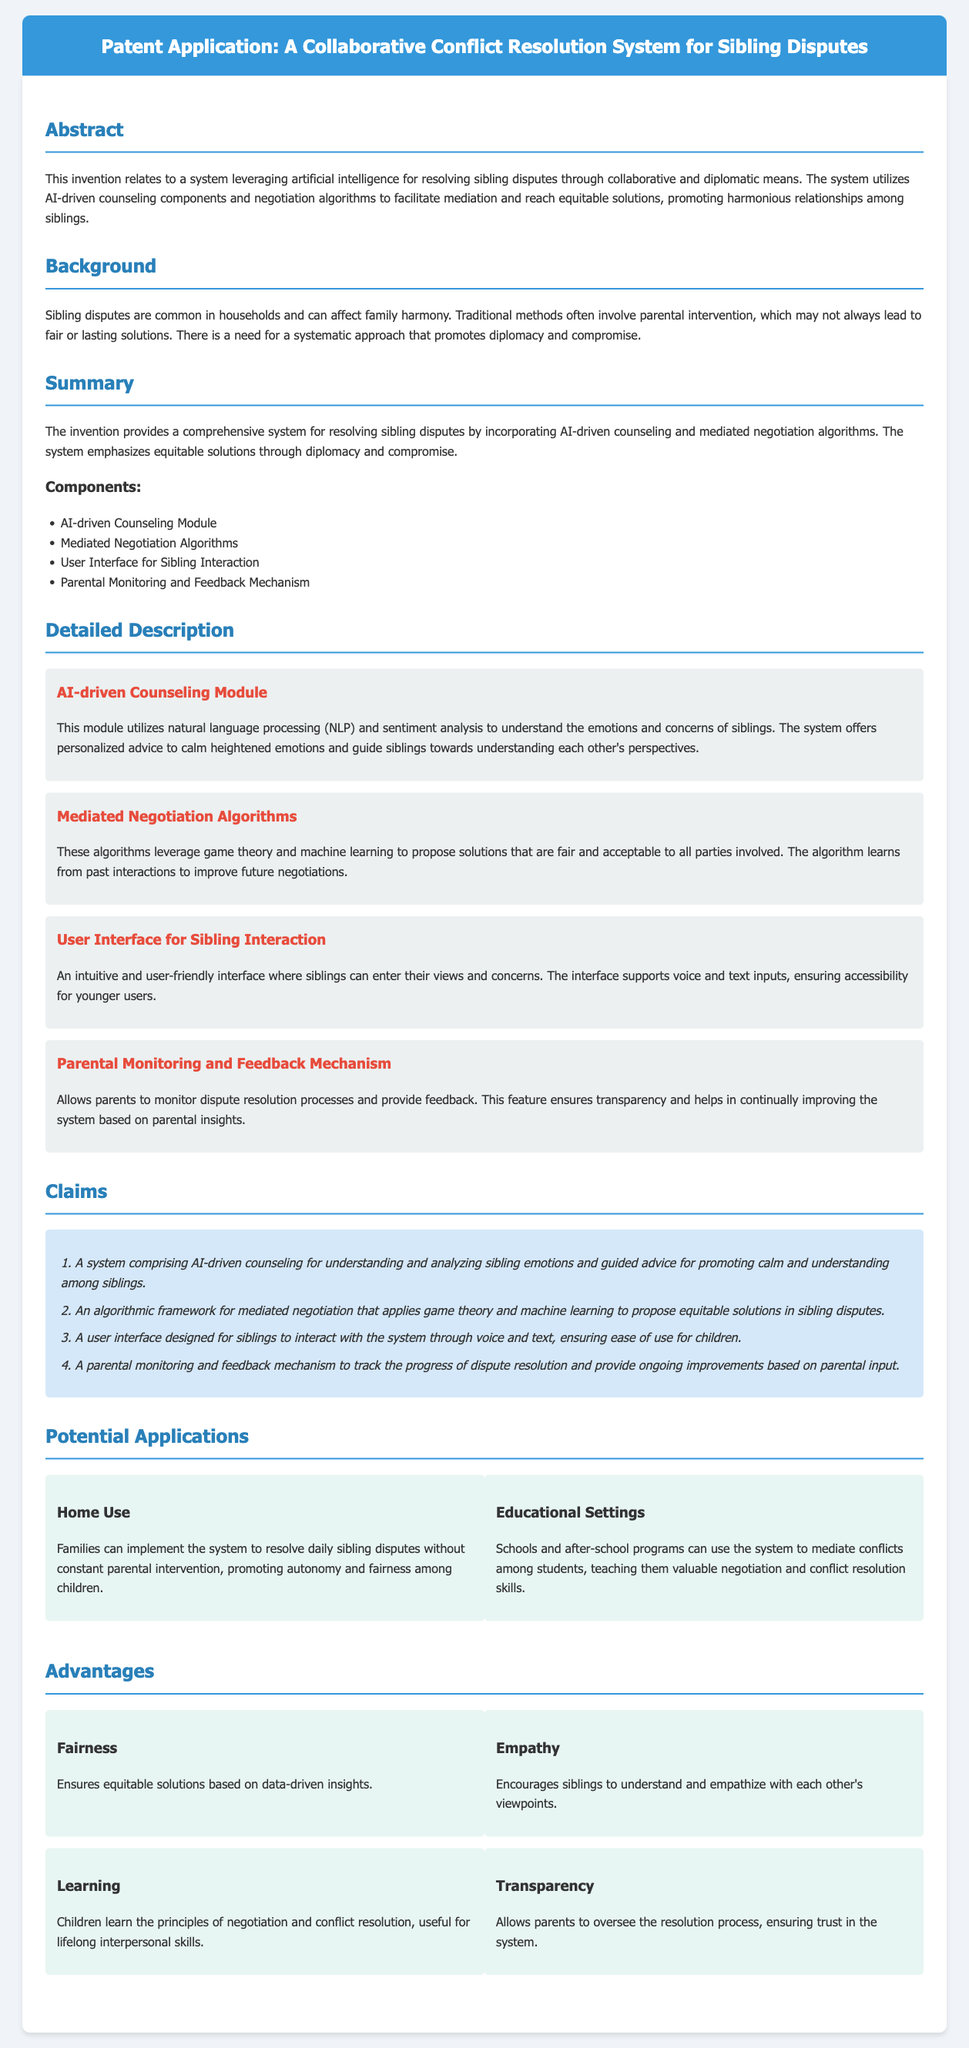What is the main purpose of the invention? The invention aims to resolve sibling disputes through collaborative and diplomatic means.
Answer: resolving sibling disputes What module uses natural language processing? The module that uses natural language processing is designed to understand emotions and concerns of siblings.
Answer: AI-driven Counseling Module How many main components are listed in the summary? The summary lists four main components of the system.
Answer: four What does the parental monitoring mechanism provide? The parental monitoring mechanism provides transparency and helps improve the system based on insights.
Answer: transparency Which theory is used in the mediation algorithm? The mediation algorithm applies game theory for proposing equitable solutions.
Answer: game theory What benefit does the system offer in educational settings? In educational settings, the system teaches valuable negotiation and conflict resolution skills among students.
Answer: negotiation and conflict resolution skills Which advantage focuses on emotional understanding? The advantage that focuses on emotional understanding is aimed at encouraging empathy between siblings.
Answer: Empathy How does the system promote fairness? The system ensures fairness through data-driven insights that lead to equitable solutions.
Answer: data-driven insights What type of interface is provided for sibling interaction? The interface designed for sibling interaction is described as intuitive and user-friendly.
Answer: intuitive and user-friendly 